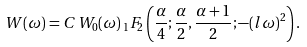Convert formula to latex. <formula><loc_0><loc_0><loc_500><loc_500>W ( \omega ) = C \, W _ { 0 } ( \omega ) \, _ { 1 } F _ { 2 } \left ( \frac { \alpha } { 4 } ; \frac { \alpha } { 2 } , \frac { \alpha + 1 } { 2 } ; - ( l \omega ) ^ { 2 } \right ) .</formula> 